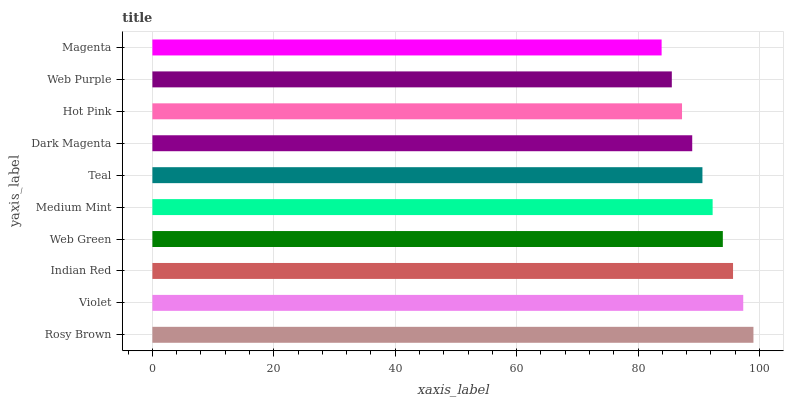Is Magenta the minimum?
Answer yes or no. Yes. Is Rosy Brown the maximum?
Answer yes or no. Yes. Is Violet the minimum?
Answer yes or no. No. Is Violet the maximum?
Answer yes or no. No. Is Rosy Brown greater than Violet?
Answer yes or no. Yes. Is Violet less than Rosy Brown?
Answer yes or no. Yes. Is Violet greater than Rosy Brown?
Answer yes or no. No. Is Rosy Brown less than Violet?
Answer yes or no. No. Is Medium Mint the high median?
Answer yes or no. Yes. Is Teal the low median?
Answer yes or no. Yes. Is Dark Magenta the high median?
Answer yes or no. No. Is Web Purple the low median?
Answer yes or no. No. 